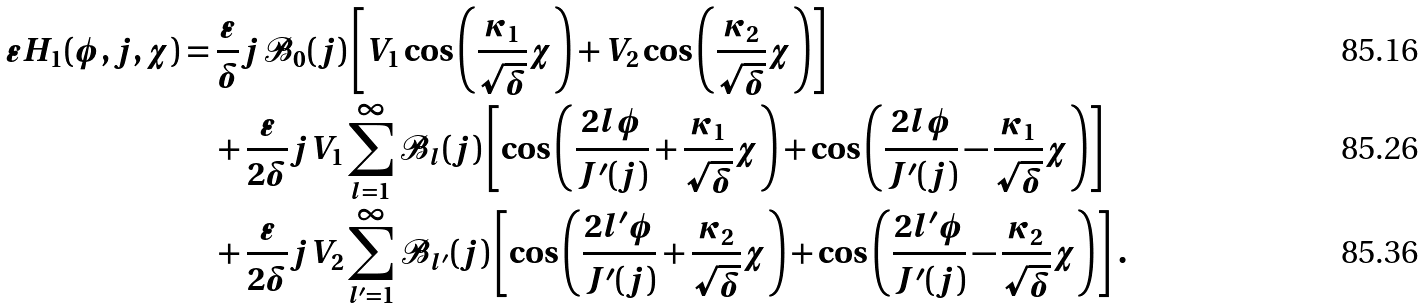<formula> <loc_0><loc_0><loc_500><loc_500>\varepsilon H _ { 1 } ( \phi , j , \chi ) & = \frac { \varepsilon } { \delta } j \mathcal { B } _ { 0 } ( j ) \left [ V _ { 1 } \cos \left ( \frac { \kappa _ { 1 } } { \sqrt { \delta } } \chi \right ) + V _ { 2 } \cos \left ( \frac { \kappa _ { 2 } } { \sqrt { \delta } } \chi \right ) \right ] \\ & \quad + \frac { \varepsilon } { 2 \delta } j V _ { 1 } \sum _ { l = 1 } ^ { \infty } \mathcal { B } _ { l } ( j ) \left [ \cos \left ( \frac { 2 l \phi } { J ^ { \prime } ( j ) } + \frac { \kappa _ { 1 } } { \sqrt { \delta } } \chi \right ) + \cos \left ( \frac { 2 l \phi } { J ^ { \prime } ( j ) } - \frac { \kappa _ { 1 } } { \sqrt { \delta } } \chi \right ) \right ] \\ & \quad + \frac { \varepsilon } { 2 \delta } j V _ { 2 } \sum _ { l ^ { \prime } = 1 } ^ { \infty } \mathcal { B } _ { l ^ { \prime } } ( j ) \left [ \cos \left ( \frac { 2 l ^ { \prime } \phi } { J ^ { \prime } ( j ) } + \frac { \kappa _ { 2 } } { \sqrt { \delta } } \chi \right ) + \cos \left ( \frac { 2 l ^ { \prime } \phi } { J ^ { \prime } ( j ) } - \frac { \kappa _ { 2 } } { \sqrt { \delta } } \chi \right ) \right ] \, .</formula> 